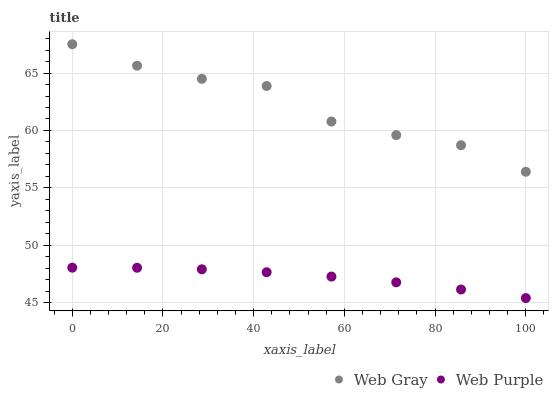Does Web Purple have the minimum area under the curve?
Answer yes or no. Yes. Does Web Gray have the maximum area under the curve?
Answer yes or no. Yes. Does Web Gray have the minimum area under the curve?
Answer yes or no. No. Is Web Purple the smoothest?
Answer yes or no. Yes. Is Web Gray the roughest?
Answer yes or no. Yes. Is Web Gray the smoothest?
Answer yes or no. No. Does Web Purple have the lowest value?
Answer yes or no. Yes. Does Web Gray have the lowest value?
Answer yes or no. No. Does Web Gray have the highest value?
Answer yes or no. Yes. Is Web Purple less than Web Gray?
Answer yes or no. Yes. Is Web Gray greater than Web Purple?
Answer yes or no. Yes. Does Web Purple intersect Web Gray?
Answer yes or no. No. 